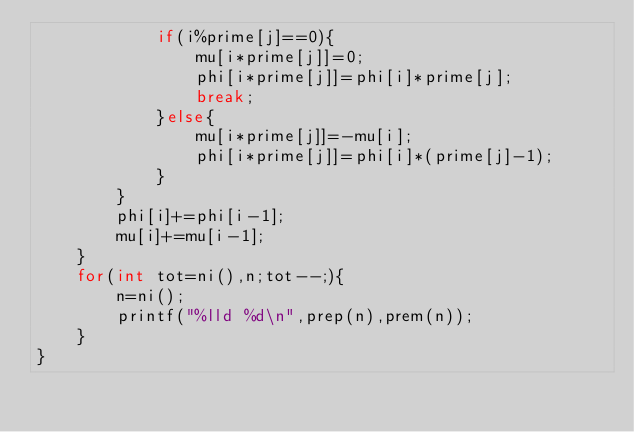Convert code to text. <code><loc_0><loc_0><loc_500><loc_500><_C++_>			if(i%prime[j]==0){
				mu[i*prime[j]]=0;
				phi[i*prime[j]]=phi[i]*prime[j];
				break;
			}else{
				mu[i*prime[j]]=-mu[i];
				phi[i*prime[j]]=phi[i]*(prime[j]-1);
			}
		}
		phi[i]+=phi[i-1];
		mu[i]+=mu[i-1];
	}
	for(int tot=ni(),n;tot--;){
		n=ni();
		printf("%lld %d\n",prep(n),prem(n));
	}
}
</code> 